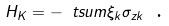Convert formula to latex. <formula><loc_0><loc_0><loc_500><loc_500>H _ { K } = - \ t s u m \xi _ { k } \sigma _ { z k } \text { .}</formula> 